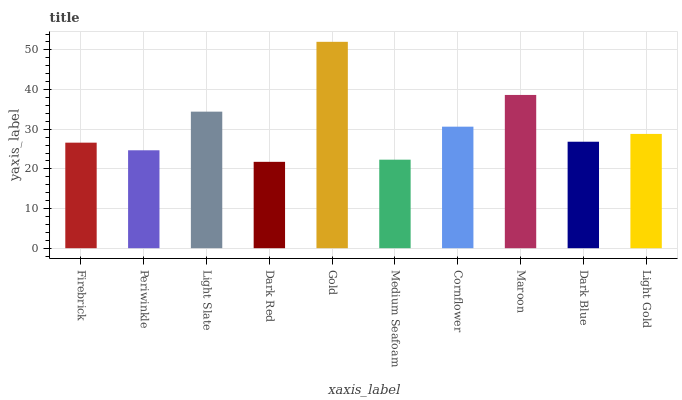Is Periwinkle the minimum?
Answer yes or no. No. Is Periwinkle the maximum?
Answer yes or no. No. Is Firebrick greater than Periwinkle?
Answer yes or no. Yes. Is Periwinkle less than Firebrick?
Answer yes or no. Yes. Is Periwinkle greater than Firebrick?
Answer yes or no. No. Is Firebrick less than Periwinkle?
Answer yes or no. No. Is Light Gold the high median?
Answer yes or no. Yes. Is Dark Blue the low median?
Answer yes or no. Yes. Is Gold the high median?
Answer yes or no. No. Is Firebrick the low median?
Answer yes or no. No. 